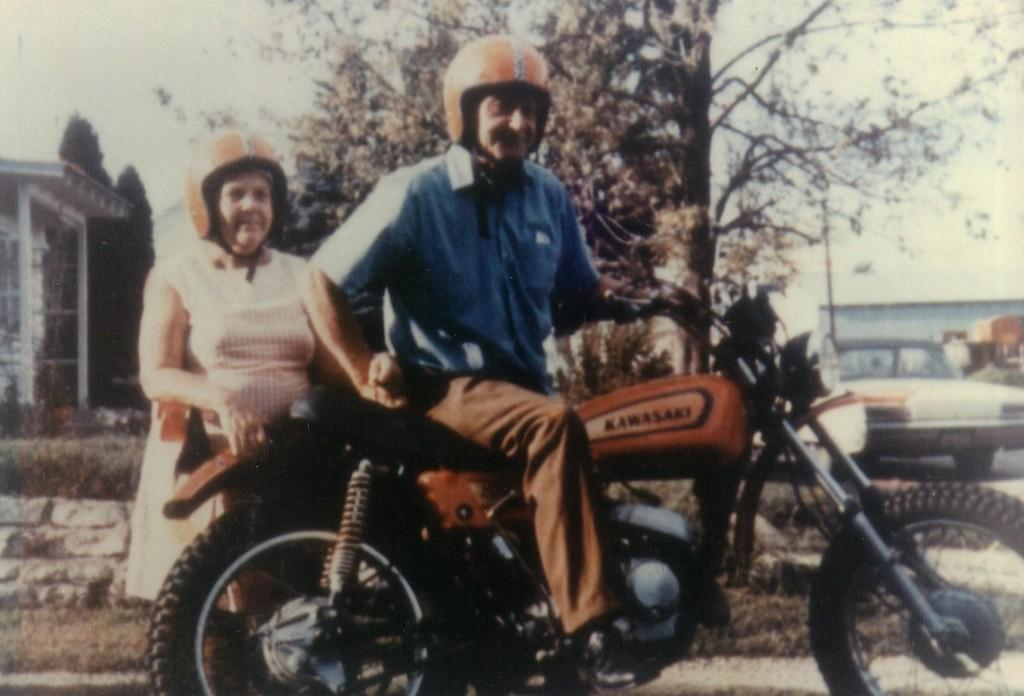What is the man in the image doing? The man is sitting on a bike in the image. Can you describe the woman's position in the image? The woman is standing on the ground in the image. Where is the birth of the cub taking place in the image? There is no mention of a cub or a birth in the image; it features a man sitting on a bike and a woman standing on the ground. 